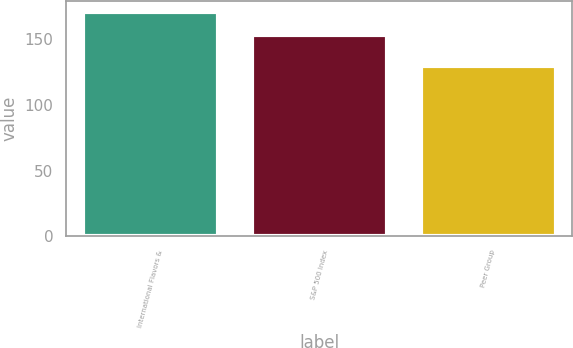Convert chart to OTSL. <chart><loc_0><loc_0><loc_500><loc_500><bar_chart><fcel>International Flavors &<fcel>S&P 500 Index<fcel>Peer Group<nl><fcel>170.7<fcel>153.57<fcel>129.66<nl></chart> 